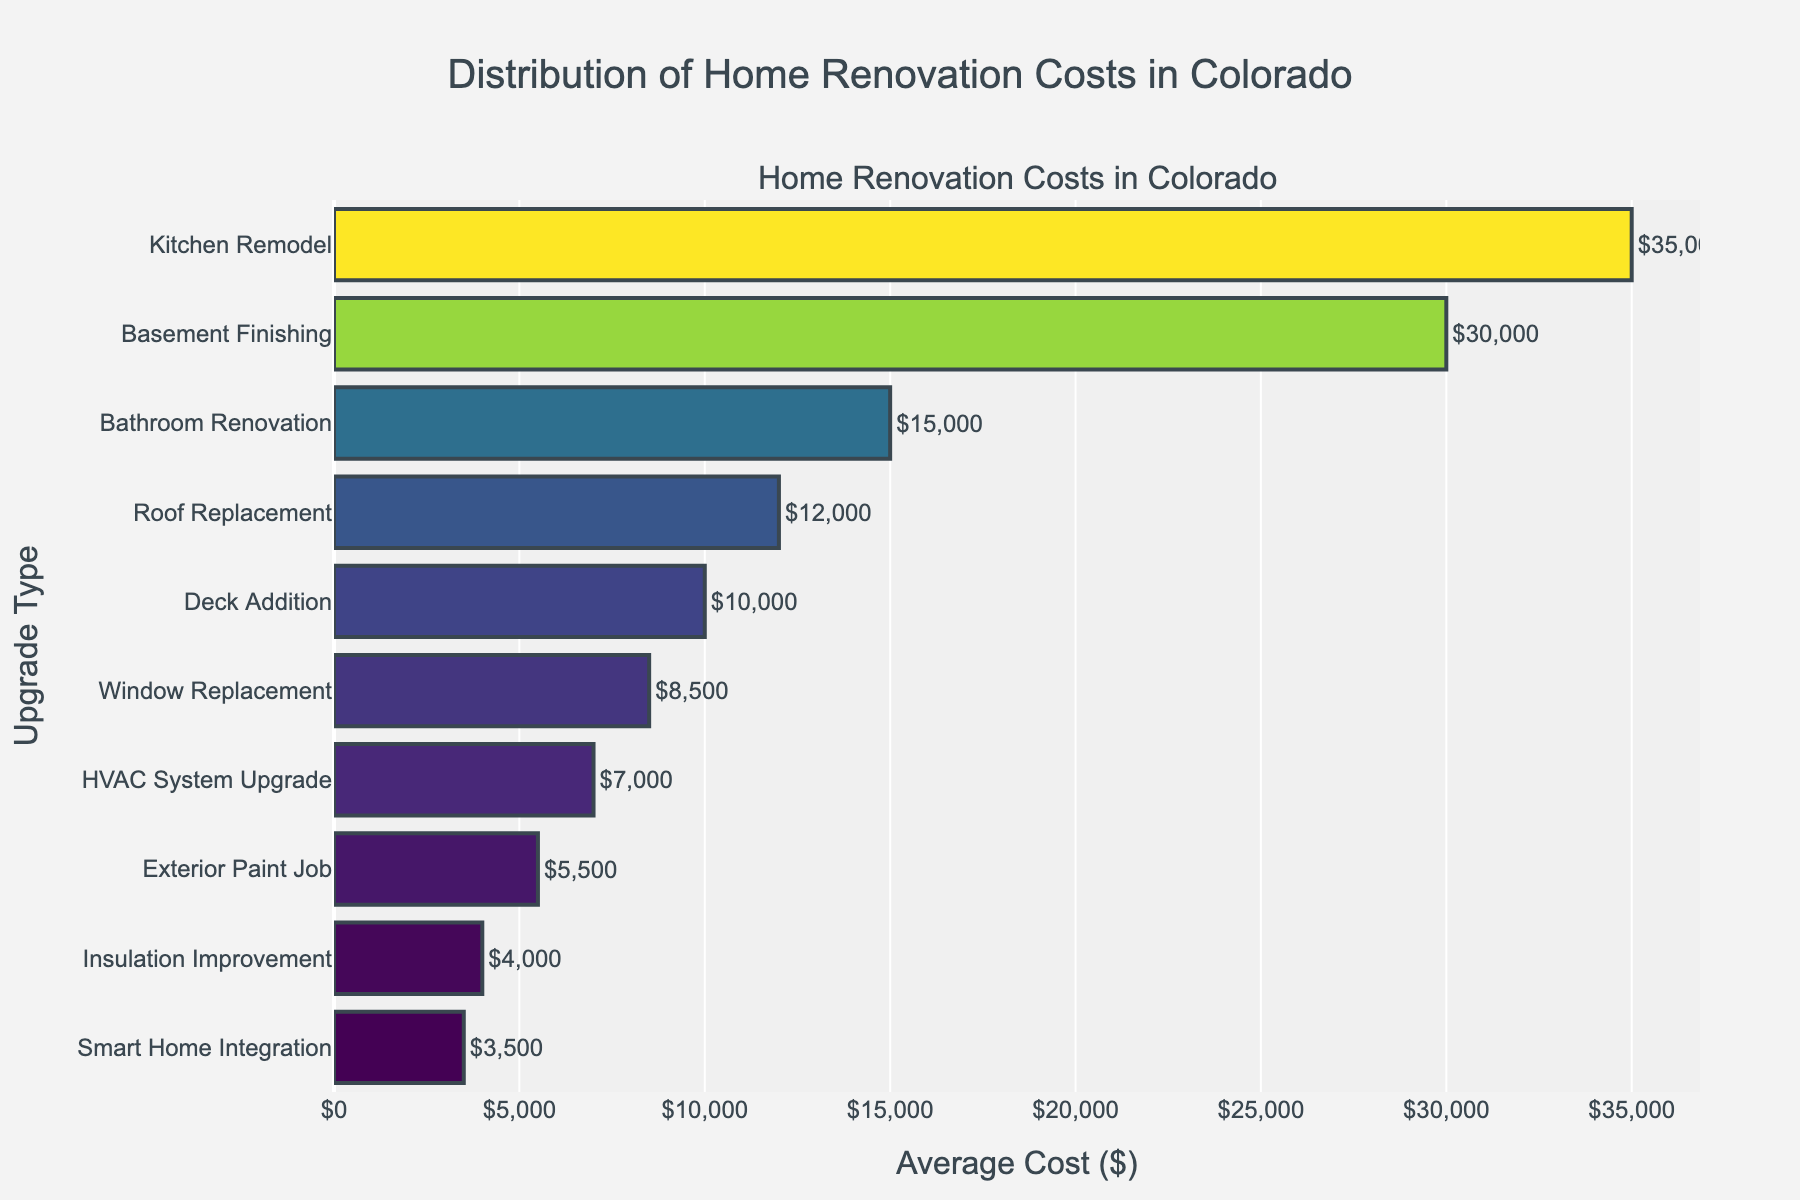What is the most expensive home renovation upgrade in Colorado according to the figure? First, look for the highest bar in the plot. The longest bar corresponds to the highest average cost. According to the figure, the "Kitchen Remodel" has the highest cost.
Answer: Kitchen Remodel What is the least expensive home renovation upgrade in Colorado according to the figure? Identify the shortest bar in the figure, which corresponds to the lowest average cost. The "Smart Home Integration" upgrade is the least expensive.
Answer: Smart Home Integration How much more expensive is a basement finishing compared to a deck addition in Colorado? Locate the bars for "Basement Finishing" and "Deck Addition". Note their costs: $30,000 for Basement Finishing and $10,000 for Deck Addition. Subtract the latter from the former to get the difference: $30,000 - $10,000.
Answer: $20,000 What is the average cost of roof replacement and insulation improvement in Colorado? Identify the bars for "Roof Replacement" and "Insulation Improvement" and note their costs: $12,000 and $4,000 respectively. Sum these two values and divide by 2 to calculate the average cost: ($12,000 + $4,000) / 2.
Answer: $8,000 Which three upgrades fall between $5,000 and $10,000 in average cost? Identify the bars falling within the range of $5,000 to $10,000. These upgrades are "Deck Addition" ($10,000), "Window Replacement" ($8,500), and "Exterior Paint Job" ($5,500).
Answer: Deck Addition, Window Replacement, Exterior Paint Job Is the cost of a bathroom renovation more or less expensive than replacing HVAC system in Colorado? Locate the bars for "Bathroom Renovation" and "HVAC System Upgrade" and compare their length. The cost of the Bathroom Renovation ($15,000) is more expensive than the HVAC System Upgrade ($7,000).
Answer: More expensive Which upgrade types cost more than $20,000 in Colorado? Identify the bars with lengths representing costs greater than $20,000. "Kitchen Remodel" ($35,000) and "Basement Finishing" ($30,000) are the upgrades costing over $20,000.
Answer: Kitchen Remodel, Basement Finishing What is the median cost of the listed home renovation upgrades in Colorado? Arrange all the values in ascending order: $3,500, $4,000, $5,500, $7,000, $8,500, $10,000, $12,000, $15,000, $30,000, $35,000. The median value separates the higher half from the lower half. The 5th and 6th values (middle ones) are $8,500 and $10,000. Calculate the median: ($8,500 + $10,000) / 2.
Answer: $9,250 By how much does the cost of a kitchen remodel surpass the cost of window replacement in Colorado? Identify the costs of "Kitchen Remodel" and "Window Replacement" in the plot. Subtract the latter’s average cost from the former: $35,000 - $8,500.
Answer: $26,500 How many different types of upgrades are listed in the figure? Count the number of bars in the figure. Each bar represents a different upgrade type. According to the figure, there are 10 different upgrade types listed.
Answer: 10 